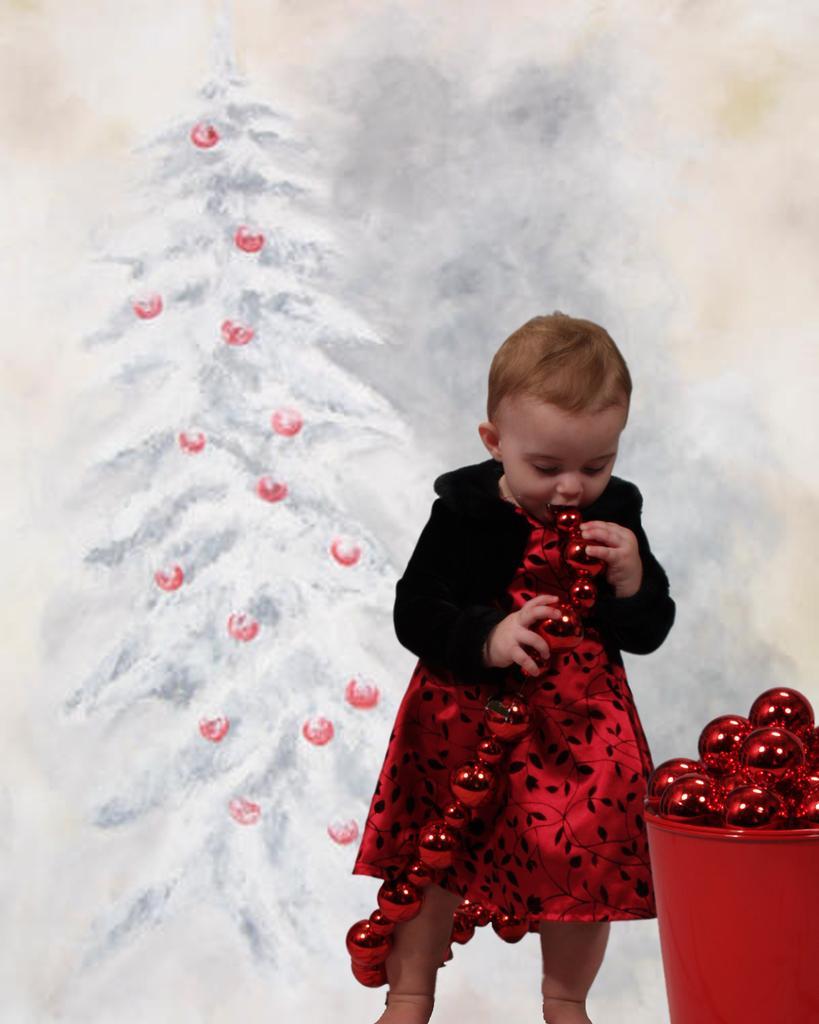Could you give a brief overview of what you see in this image? In the picture I can see one small girl is playing with some objects. On the right of the image I can see one bucket with some objects is in red color. 